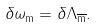<formula> <loc_0><loc_0><loc_500><loc_500>\delta \omega _ { \text {m} } = \delta \Lambda _ { \overline { \text {m} } } .</formula> 